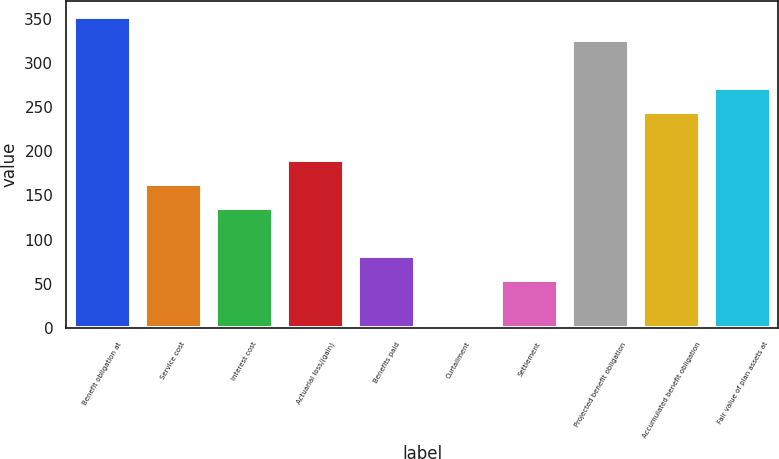Convert chart. <chart><loc_0><loc_0><loc_500><loc_500><bar_chart><fcel>Benefit obligation at<fcel>Service cost<fcel>Interest cost<fcel>Actuarial loss/(gain)<fcel>Benefits paid<fcel>Curtailment<fcel>Settlement<fcel>Projected benefit obligation<fcel>Accumulated benefit obligation<fcel>Fair value of plan assets at<nl><fcel>352.26<fcel>162.7<fcel>135.62<fcel>189.78<fcel>81.46<fcel>0.22<fcel>54.38<fcel>325.18<fcel>243.94<fcel>271.02<nl></chart> 